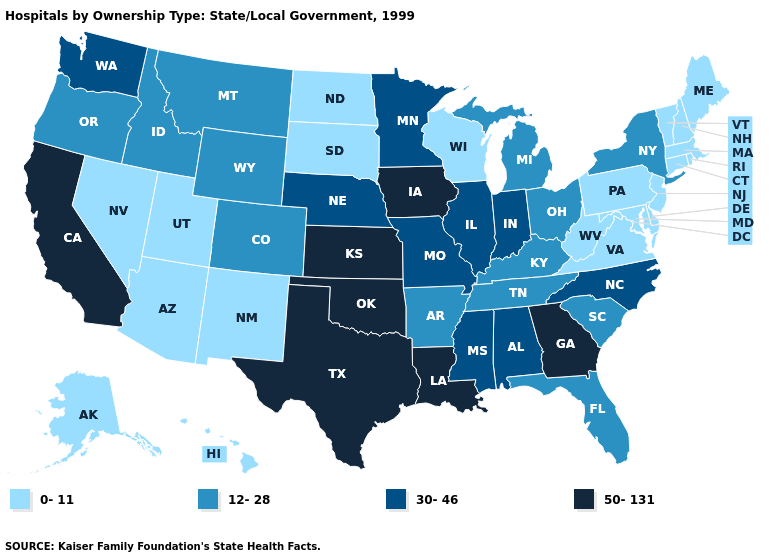What is the lowest value in states that border Louisiana?
Be succinct. 12-28. What is the value of Tennessee?
Be succinct. 12-28. Does Wisconsin have the highest value in the MidWest?
Keep it brief. No. Name the states that have a value in the range 50-131?
Write a very short answer. California, Georgia, Iowa, Kansas, Louisiana, Oklahoma, Texas. What is the lowest value in the USA?
Answer briefly. 0-11. Name the states that have a value in the range 30-46?
Quick response, please. Alabama, Illinois, Indiana, Minnesota, Mississippi, Missouri, Nebraska, North Carolina, Washington. What is the value of Nevada?
Short answer required. 0-11. Name the states that have a value in the range 12-28?
Be succinct. Arkansas, Colorado, Florida, Idaho, Kentucky, Michigan, Montana, New York, Ohio, Oregon, South Carolina, Tennessee, Wyoming. Name the states that have a value in the range 30-46?
Write a very short answer. Alabama, Illinois, Indiana, Minnesota, Mississippi, Missouri, Nebraska, North Carolina, Washington. Among the states that border Michigan , which have the lowest value?
Answer briefly. Wisconsin. Which states have the lowest value in the West?
Concise answer only. Alaska, Arizona, Hawaii, Nevada, New Mexico, Utah. Does Kansas have the highest value in the USA?
Quick response, please. Yes. What is the value of Utah?
Concise answer only. 0-11. Does the first symbol in the legend represent the smallest category?
Short answer required. Yes. 